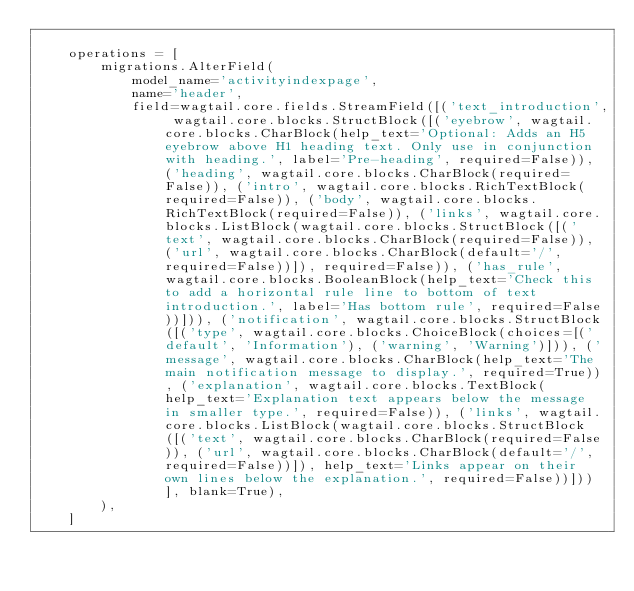Convert code to text. <code><loc_0><loc_0><loc_500><loc_500><_Python_>
    operations = [
        migrations.AlterField(
            model_name='activityindexpage',
            name='header',
            field=wagtail.core.fields.StreamField([('text_introduction', wagtail.core.blocks.StructBlock([('eyebrow', wagtail.core.blocks.CharBlock(help_text='Optional: Adds an H5 eyebrow above H1 heading text. Only use in conjunction with heading.', label='Pre-heading', required=False)), ('heading', wagtail.core.blocks.CharBlock(required=False)), ('intro', wagtail.core.blocks.RichTextBlock(required=False)), ('body', wagtail.core.blocks.RichTextBlock(required=False)), ('links', wagtail.core.blocks.ListBlock(wagtail.core.blocks.StructBlock([('text', wagtail.core.blocks.CharBlock(required=False)), ('url', wagtail.core.blocks.CharBlock(default='/', required=False))]), required=False)), ('has_rule', wagtail.core.blocks.BooleanBlock(help_text='Check this to add a horizontal rule line to bottom of text introduction.', label='Has bottom rule', required=False))])), ('notification', wagtail.core.blocks.StructBlock([('type', wagtail.core.blocks.ChoiceBlock(choices=[('default', 'Information'), ('warning', 'Warning')])), ('message', wagtail.core.blocks.CharBlock(help_text='The main notification message to display.', required=True)), ('explanation', wagtail.core.blocks.TextBlock(help_text='Explanation text appears below the message in smaller type.', required=False)), ('links', wagtail.core.blocks.ListBlock(wagtail.core.blocks.StructBlock([('text', wagtail.core.blocks.CharBlock(required=False)), ('url', wagtail.core.blocks.CharBlock(default='/', required=False))]), help_text='Links appear on their own lines below the explanation.', required=False))]))], blank=True),
        ),
    ]
</code> 